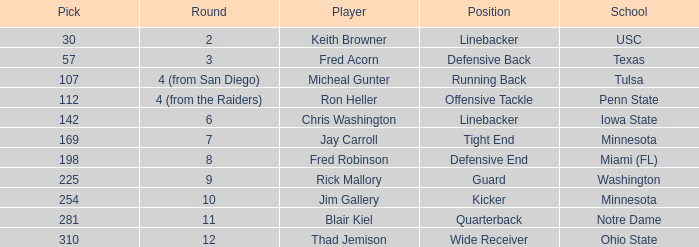What is the pick number of Penn State? 112.0. 